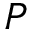Convert formula to latex. <formula><loc_0><loc_0><loc_500><loc_500>P</formula> 